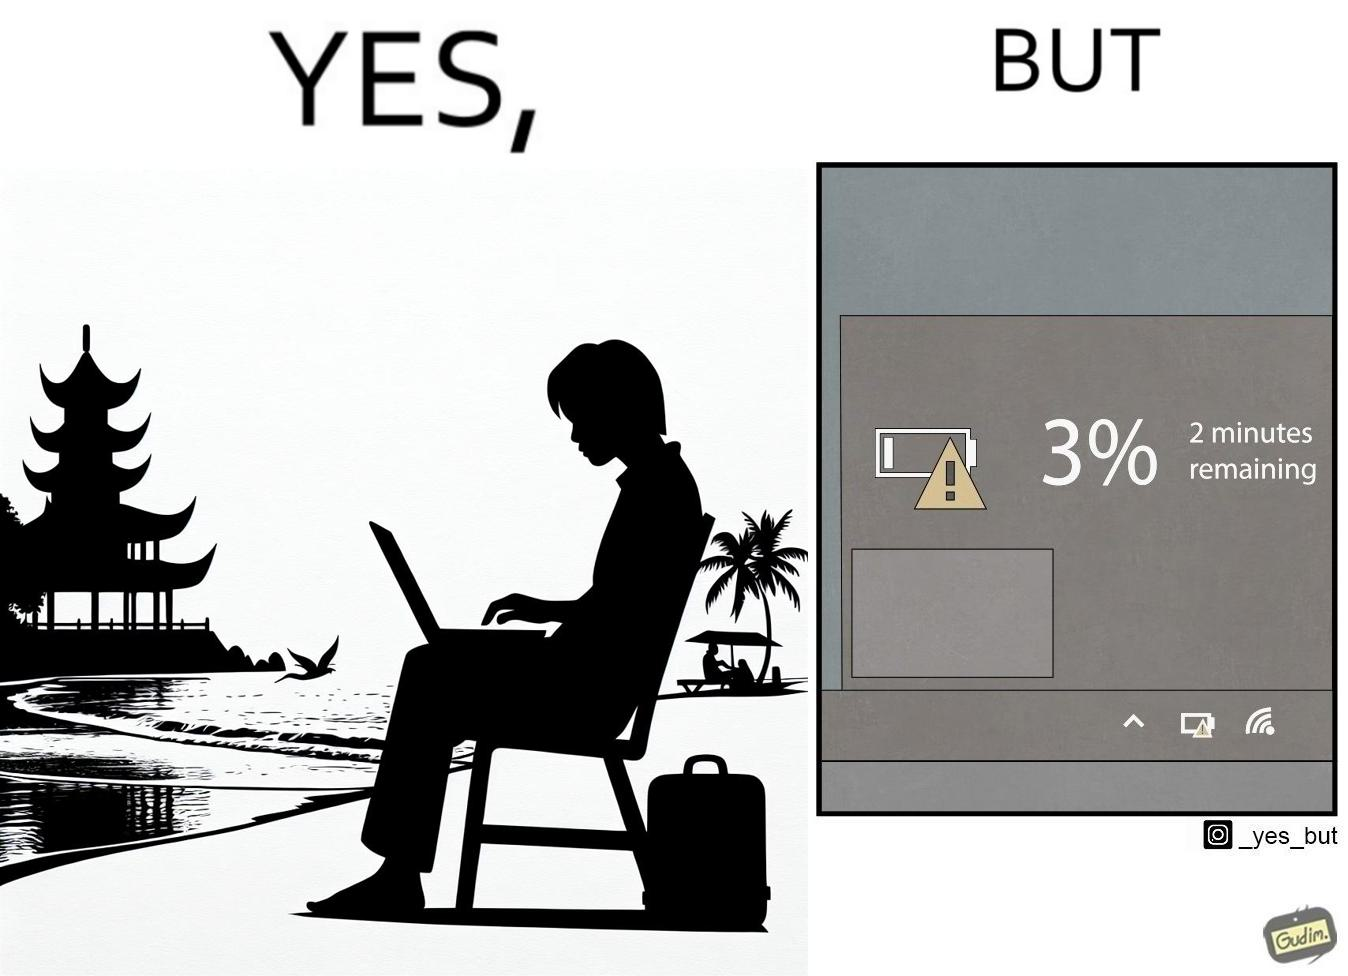Describe what you see in this image. The image is ironical, as a person is working on a laptop in a beach, which looks like a soothing and calm environment to work. However, the laptop is about to get discharged, and there is probably no electric supply to keep the laptop open while working on the beach, turning the situation into an inconvenience. 